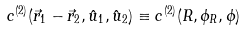Convert formula to latex. <formula><loc_0><loc_0><loc_500><loc_500>c ^ { ( 2 ) } ( \vec { r } _ { 1 } - \vec { r } _ { 2 } , \hat { u } _ { 1 } , \hat { u } _ { 2 } ) \equiv c ^ { ( 2 ) } ( R , \phi _ { R } , \phi )</formula> 